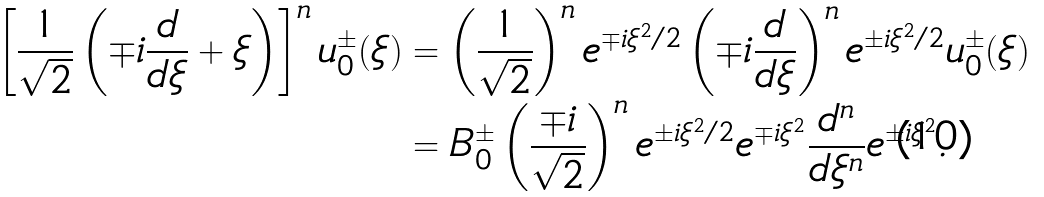<formula> <loc_0><loc_0><loc_500><loc_500>\left [ \frac { 1 } { \sqrt { 2 } } \left ( \mp i \frac { d } { d \xi } + \xi \right ) \right ] ^ { n } u ^ { \pm } _ { 0 } ( \xi ) & = \left ( \frac { 1 } { \sqrt { 2 } } \right ) ^ { n } e ^ { \mp i \xi ^ { 2 } / 2 } \left ( \mp i \frac { d } { d \xi } \right ) ^ { n } e ^ { \pm i \xi ^ { 2 } / 2 } u ^ { \pm } _ { 0 } ( \xi ) \\ & = B ^ { \pm } _ { 0 } \left ( \frac { \mp i } { \sqrt { 2 } } \right ) ^ { n } e ^ { \pm i \xi ^ { 2 } / 2 } e ^ { \mp i \xi ^ { 2 } } \frac { d ^ { n } } { d \xi ^ { n } } e ^ { \pm i \xi ^ { 2 } } .</formula> 